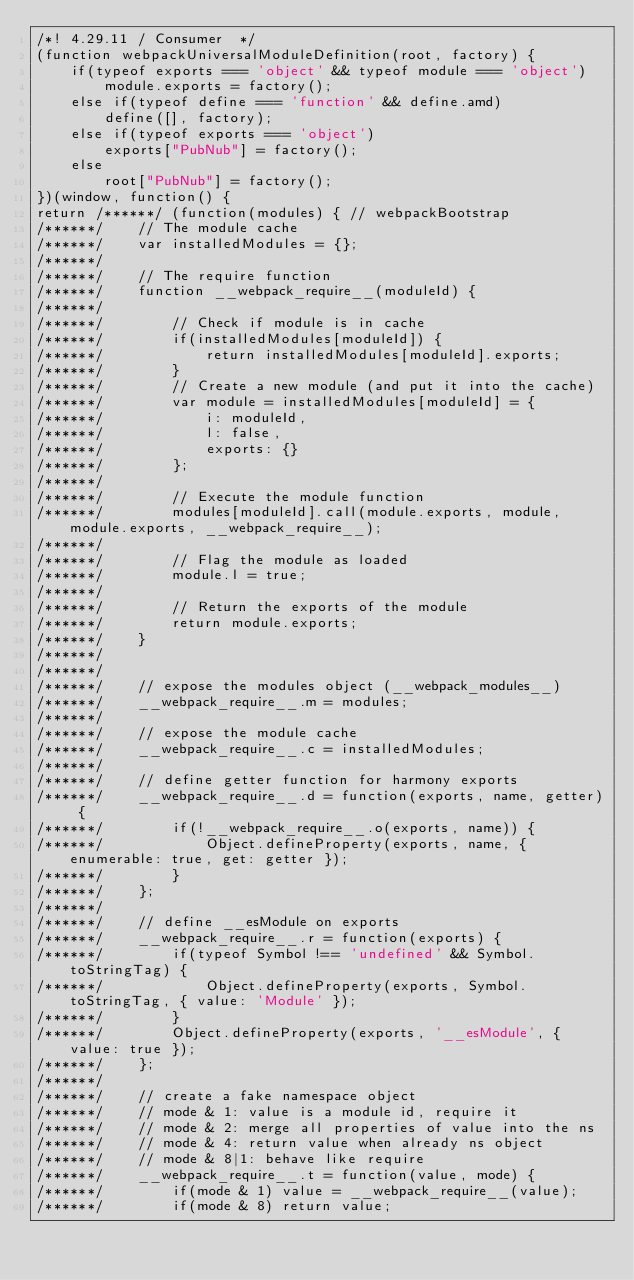Convert code to text. <code><loc_0><loc_0><loc_500><loc_500><_JavaScript_>/*! 4.29.11 / Consumer  */
(function webpackUniversalModuleDefinition(root, factory) {
	if(typeof exports === 'object' && typeof module === 'object')
		module.exports = factory();
	else if(typeof define === 'function' && define.amd)
		define([], factory);
	else if(typeof exports === 'object')
		exports["PubNub"] = factory();
	else
		root["PubNub"] = factory();
})(window, function() {
return /******/ (function(modules) { // webpackBootstrap
/******/ 	// The module cache
/******/ 	var installedModules = {};
/******/
/******/ 	// The require function
/******/ 	function __webpack_require__(moduleId) {
/******/
/******/ 		// Check if module is in cache
/******/ 		if(installedModules[moduleId]) {
/******/ 			return installedModules[moduleId].exports;
/******/ 		}
/******/ 		// Create a new module (and put it into the cache)
/******/ 		var module = installedModules[moduleId] = {
/******/ 			i: moduleId,
/******/ 			l: false,
/******/ 			exports: {}
/******/ 		};
/******/
/******/ 		// Execute the module function
/******/ 		modules[moduleId].call(module.exports, module, module.exports, __webpack_require__);
/******/
/******/ 		// Flag the module as loaded
/******/ 		module.l = true;
/******/
/******/ 		// Return the exports of the module
/******/ 		return module.exports;
/******/ 	}
/******/
/******/
/******/ 	// expose the modules object (__webpack_modules__)
/******/ 	__webpack_require__.m = modules;
/******/
/******/ 	// expose the module cache
/******/ 	__webpack_require__.c = installedModules;
/******/
/******/ 	// define getter function for harmony exports
/******/ 	__webpack_require__.d = function(exports, name, getter) {
/******/ 		if(!__webpack_require__.o(exports, name)) {
/******/ 			Object.defineProperty(exports, name, { enumerable: true, get: getter });
/******/ 		}
/******/ 	};
/******/
/******/ 	// define __esModule on exports
/******/ 	__webpack_require__.r = function(exports) {
/******/ 		if(typeof Symbol !== 'undefined' && Symbol.toStringTag) {
/******/ 			Object.defineProperty(exports, Symbol.toStringTag, { value: 'Module' });
/******/ 		}
/******/ 		Object.defineProperty(exports, '__esModule', { value: true });
/******/ 	};
/******/
/******/ 	// create a fake namespace object
/******/ 	// mode & 1: value is a module id, require it
/******/ 	// mode & 2: merge all properties of value into the ns
/******/ 	// mode & 4: return value when already ns object
/******/ 	// mode & 8|1: behave like require
/******/ 	__webpack_require__.t = function(value, mode) {
/******/ 		if(mode & 1) value = __webpack_require__(value);
/******/ 		if(mode & 8) return value;</code> 